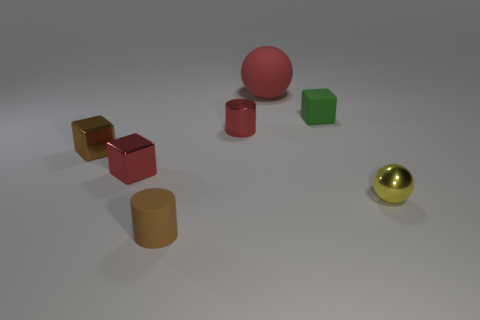Add 1 small shiny cylinders. How many objects exist? 8 Subtract all green blocks. How many blocks are left? 2 Subtract all metal cubes. How many cubes are left? 1 Subtract 0 brown spheres. How many objects are left? 7 Subtract all blocks. How many objects are left? 4 Subtract 1 blocks. How many blocks are left? 2 Subtract all yellow balls. Subtract all yellow cubes. How many balls are left? 1 Subtract all purple cylinders. How many red balls are left? 1 Subtract all tiny brown metallic cubes. Subtract all green cubes. How many objects are left? 5 Add 1 big matte balls. How many big matte balls are left? 2 